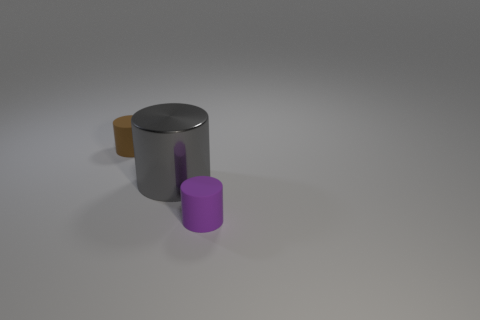Subtract 1 cylinders. How many cylinders are left? 2 Add 2 large purple things. How many objects exist? 5 Add 1 tiny cyan shiny balls. How many tiny cyan shiny balls exist? 1 Subtract 0 gray cubes. How many objects are left? 3 Subtract all large gray cylinders. Subtract all big objects. How many objects are left? 1 Add 1 purple cylinders. How many purple cylinders are left? 2 